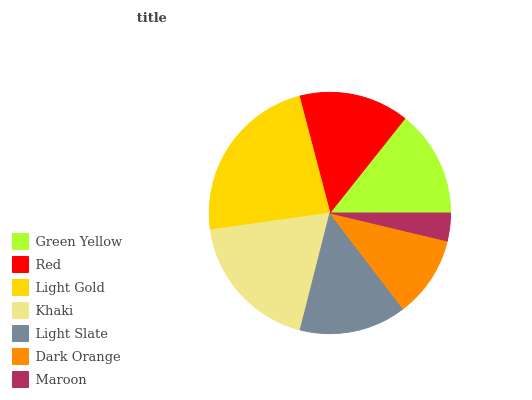Is Maroon the minimum?
Answer yes or no. Yes. Is Light Gold the maximum?
Answer yes or no. Yes. Is Red the minimum?
Answer yes or no. No. Is Red the maximum?
Answer yes or no. No. Is Red greater than Green Yellow?
Answer yes or no. Yes. Is Green Yellow less than Red?
Answer yes or no. Yes. Is Green Yellow greater than Red?
Answer yes or no. No. Is Red less than Green Yellow?
Answer yes or no. No. Is Light Slate the high median?
Answer yes or no. Yes. Is Light Slate the low median?
Answer yes or no. Yes. Is Maroon the high median?
Answer yes or no. No. Is Light Gold the low median?
Answer yes or no. No. 